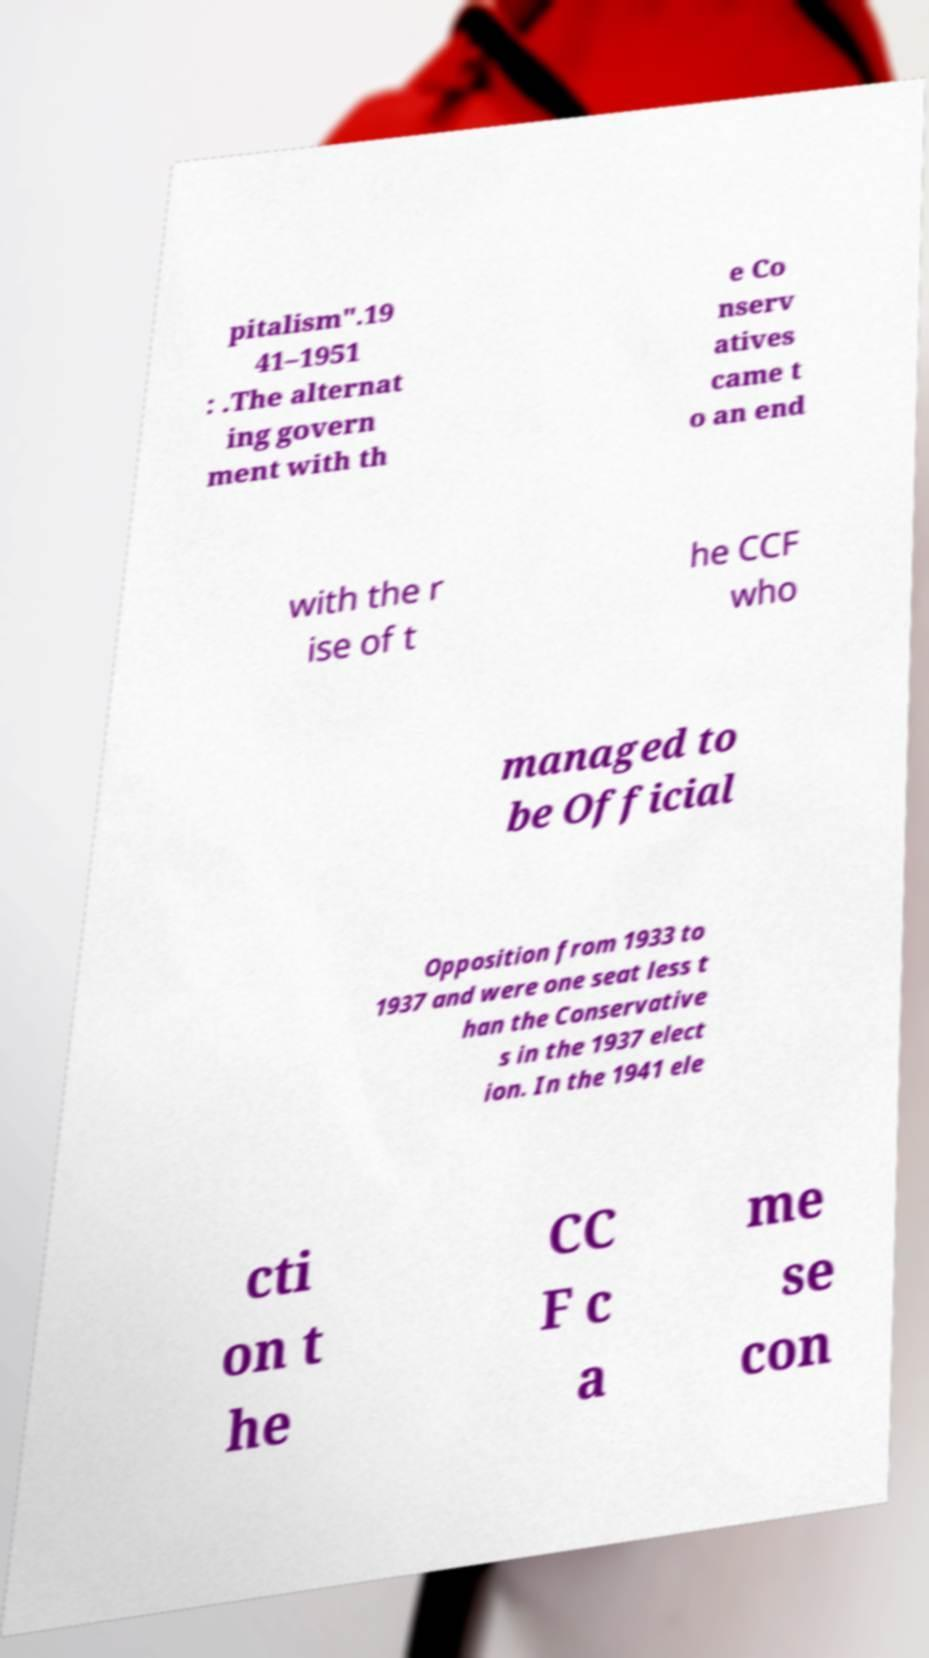Please read and relay the text visible in this image. What does it say? pitalism".19 41–1951 : .The alternat ing govern ment with th e Co nserv atives came t o an end with the r ise of t he CCF who managed to be Official Opposition from 1933 to 1937 and were one seat less t han the Conservative s in the 1937 elect ion. In the 1941 ele cti on t he CC F c a me se con 